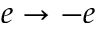<formula> <loc_0><loc_0><loc_500><loc_500>e \to - e</formula> 